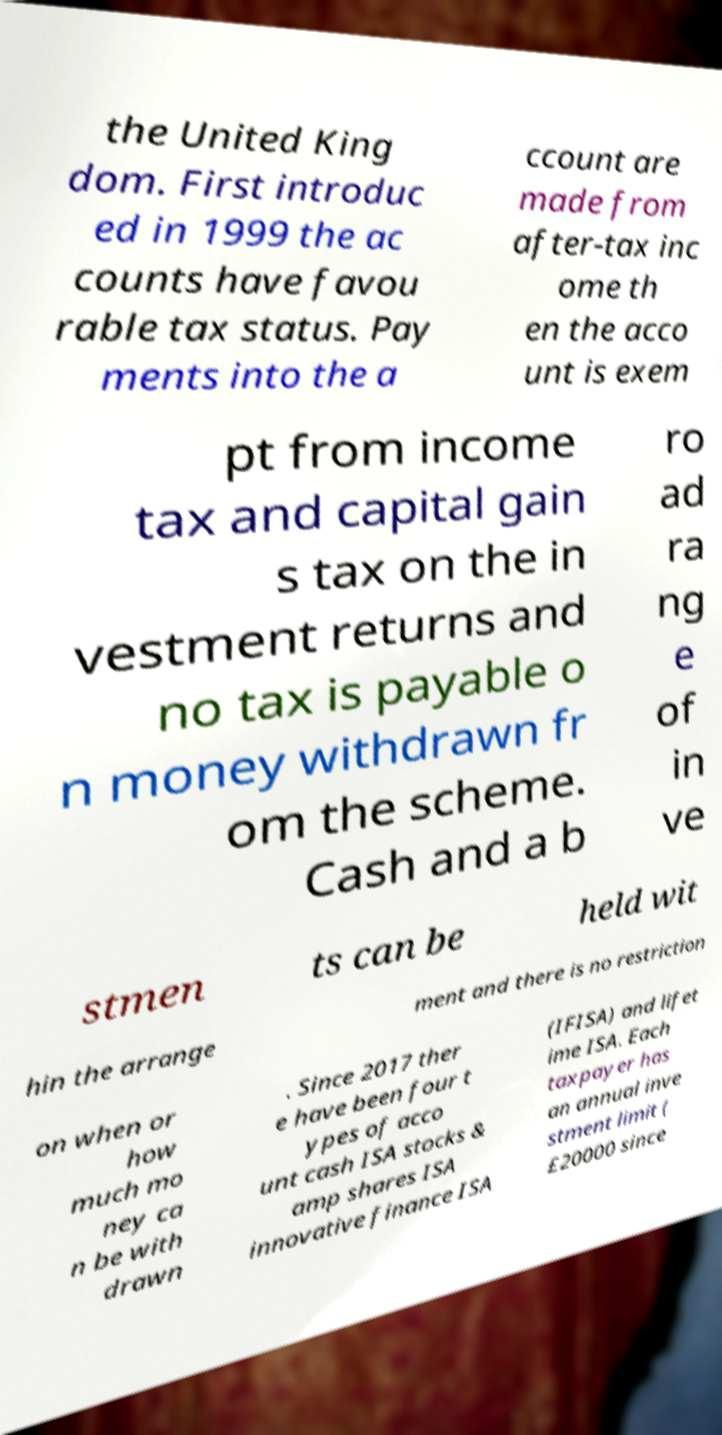Please read and relay the text visible in this image. What does it say? the United King dom. First introduc ed in 1999 the ac counts have favou rable tax status. Pay ments into the a ccount are made from after-tax inc ome th en the acco unt is exem pt from income tax and capital gain s tax on the in vestment returns and no tax is payable o n money withdrawn fr om the scheme. Cash and a b ro ad ra ng e of in ve stmen ts can be held wit hin the arrange ment and there is no restriction on when or how much mo ney ca n be with drawn . Since 2017 ther e have been four t ypes of acco unt cash ISA stocks & amp shares ISA innovative finance ISA (IFISA) and lifet ime ISA. Each taxpayer has an annual inve stment limit ( £20000 since 